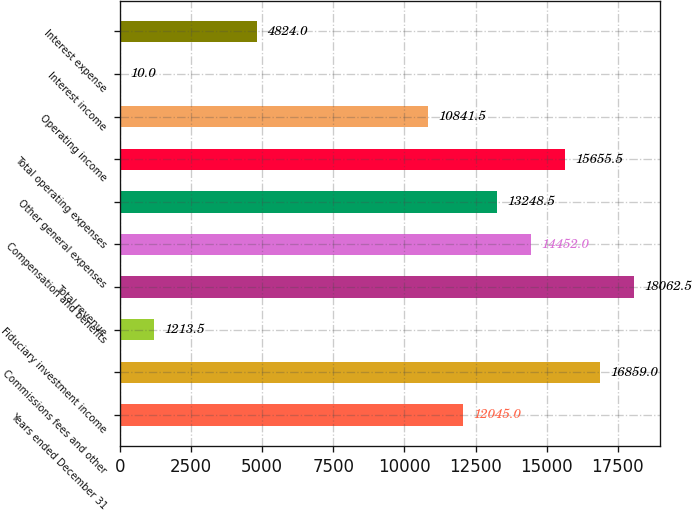<chart> <loc_0><loc_0><loc_500><loc_500><bar_chart><fcel>Years ended December 31<fcel>Commissions fees and other<fcel>Fiduciary investment income<fcel>Total revenue<fcel>Compensation and benefits<fcel>Other general expenses<fcel>Total operating expenses<fcel>Operating income<fcel>Interest income<fcel>Interest expense<nl><fcel>12045<fcel>16859<fcel>1213.5<fcel>18062.5<fcel>14452<fcel>13248.5<fcel>15655.5<fcel>10841.5<fcel>10<fcel>4824<nl></chart> 